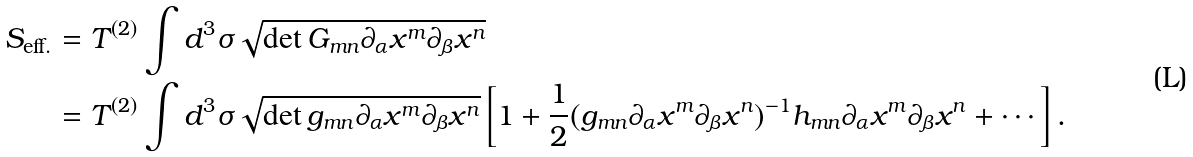Convert formula to latex. <formula><loc_0><loc_0><loc_500><loc_500>S _ { \text {eff.} } & = T ^ { ( 2 ) } \int d ^ { 3 } \sigma \sqrt { \det G _ { m n } \partial _ { \alpha } x ^ { m } \partial _ { \beta } x ^ { n } } \\ & = T ^ { ( 2 ) } \int d ^ { 3 } \sigma \sqrt { \det g _ { m n } \partial _ { \alpha } x ^ { m } \partial _ { \beta } x ^ { n } } \left [ 1 + \frac { 1 } { 2 } ( g _ { m n } \partial _ { \alpha } x ^ { m } \partial _ { \beta } x ^ { n } ) ^ { - 1 } h _ { m n } \partial _ { \alpha } x ^ { m } \partial _ { \beta } x ^ { n } + \cdots \right ] .</formula> 